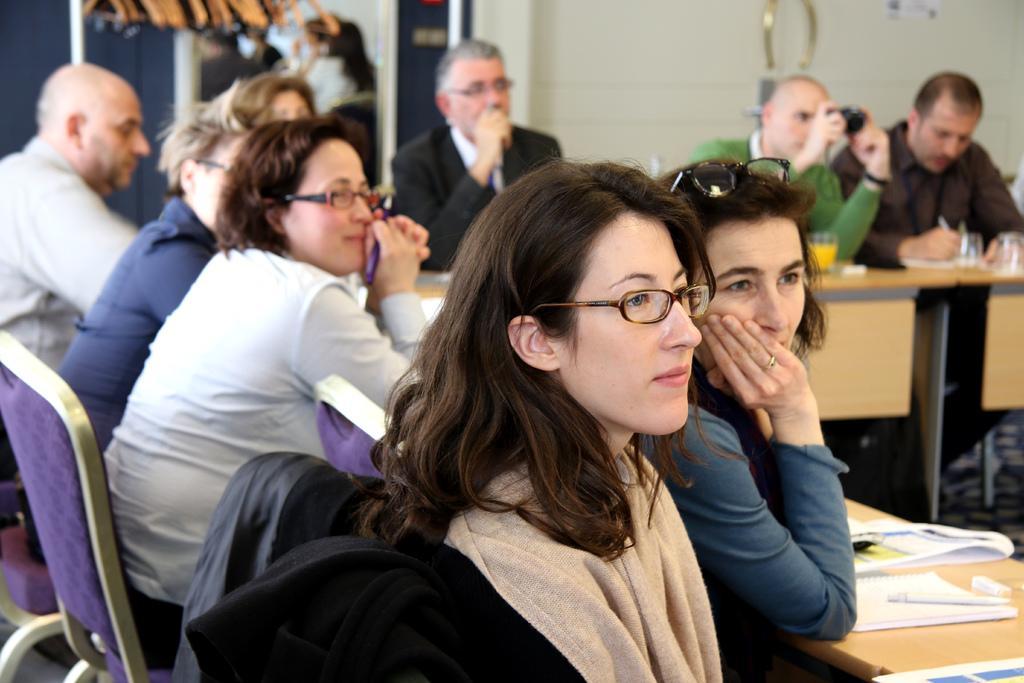Please provide a concise description of this image. A group of people are sitting at a table and looking at something. 